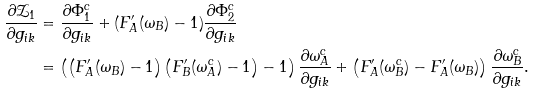<formula> <loc_0><loc_0><loc_500><loc_500>\frac { \partial \mathcal { Z } _ { 1 } } { \partial g _ { i k } } & = \frac { \partial \Phi _ { 1 } ^ { c } } { \partial g _ { i k } } + ( F _ { A } ^ { \prime } ( \omega _ { B } ) - 1 ) \frac { \partial \Phi _ { 2 } ^ { c } } { \partial g _ { i k } } \\ & = \left ( \left ( F _ { A } ^ { \prime } ( \omega _ { B } ) - 1 \right ) \left ( F _ { B } ^ { \prime } ( \omega _ { A } ^ { c } ) - 1 \right ) - 1 \right ) \frac { \partial \omega _ { A } ^ { c } } { \partial g _ { i k } } + \left ( F _ { A } ^ { \prime } ( \omega _ { B } ^ { c } ) - F _ { A } ^ { \prime } ( \omega _ { B } ) \right ) \frac { \partial \omega _ { B } ^ { c } } { \partial g _ { i k } } .</formula> 